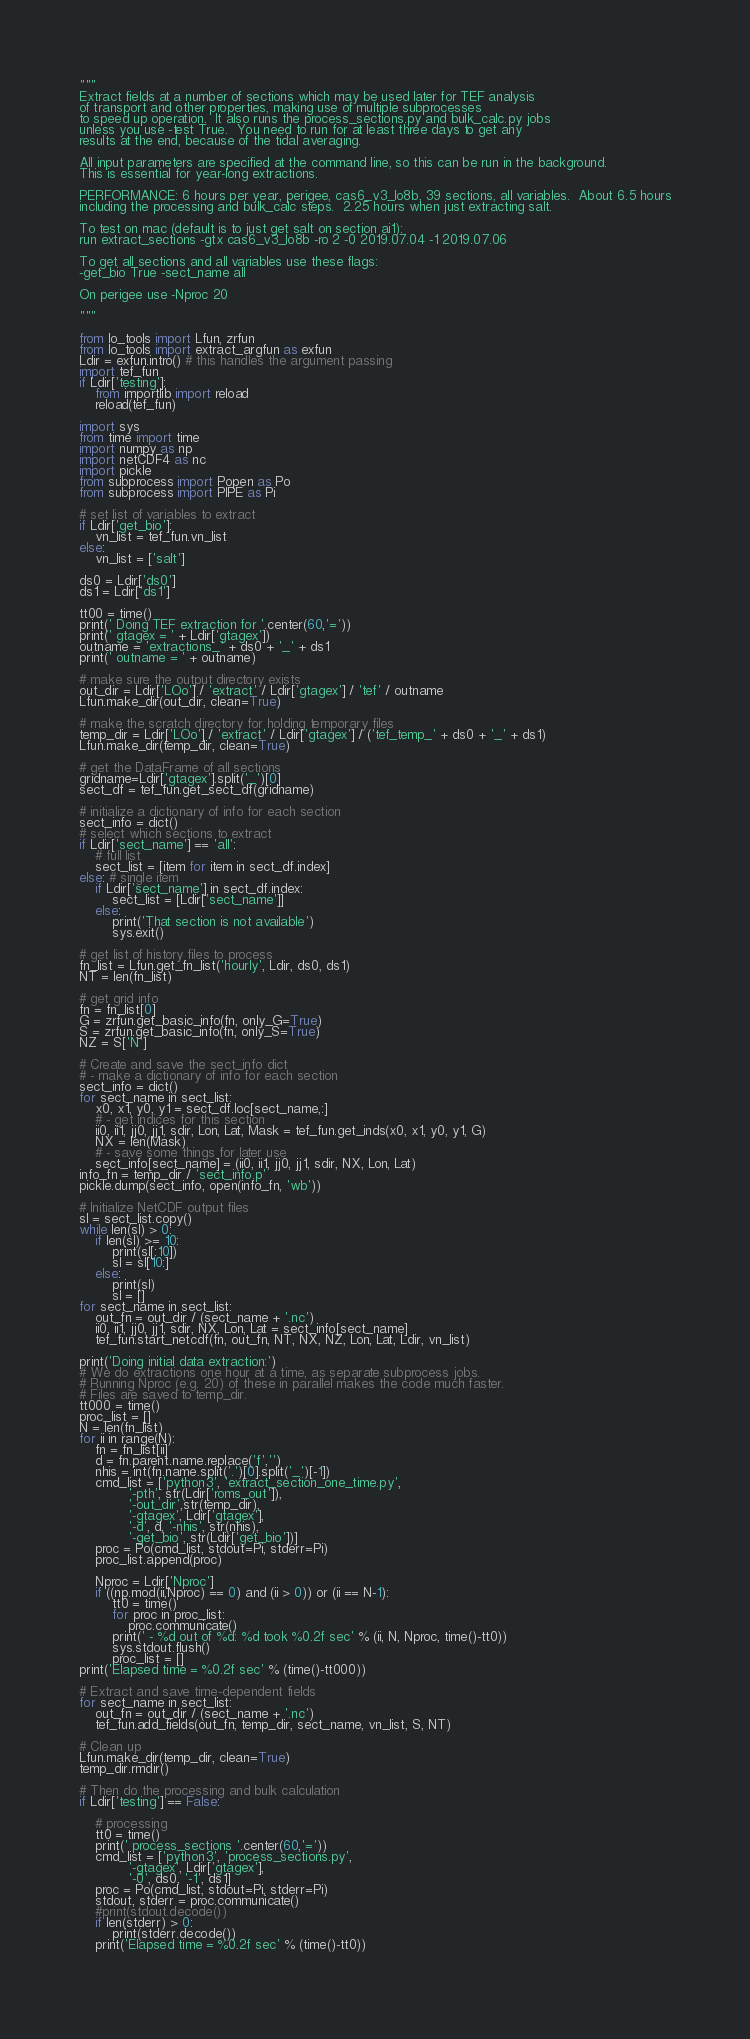<code> <loc_0><loc_0><loc_500><loc_500><_Python_>"""
Extract fields at a number of sections which may be used later for TEF analysis
of transport and other properties, making use of multiple subprocesses
to speed up operation.  It also runs the process_sections.py and bulk_calc.py jobs
unless you use -test True.  You need to run for at least three days to get any
results at the end, because of the tidal averaging.

All input parameters are specified at the command line, so this can be run in the background.
This is essential for year-long extractions.

PERFORMANCE: 6 hours per year, perigee, cas6_v3_lo8b, 39 sections, all variables.  About 6.5 hours
including the processing and bulk_calc steps.  2.25 hours when just extracting salt.

To test on mac (default is to just get salt on section ai1):
run extract_sections -gtx cas6_v3_lo8b -ro 2 -0 2019.07.04 -1 2019.07.06

To get all sections and all variables use these flags:
-get_bio True -sect_name all

On perigee use -Nproc 20

"""

from lo_tools import Lfun, zrfun
from lo_tools import extract_argfun as exfun
Ldir = exfun.intro() # this handles the argument passing
import tef_fun
if Ldir['testing']:
    from importlib import reload
    reload(tef_fun)

import sys
from time import time
import numpy as np
import netCDF4 as nc
import pickle
from subprocess import Popen as Po
from subprocess import PIPE as Pi
    
# set list of variables to extract
if Ldir['get_bio']:
    vn_list = tef_fun.vn_list
else:
    vn_list = ['salt']

ds0 = Ldir['ds0']
ds1 = Ldir['ds1']

tt00 = time()
print(' Doing TEF extraction for '.center(60,'='))
print(' gtagex = ' + Ldir['gtagex'])
outname = 'extractions_' + ds0 + '_' + ds1
print(' outname = ' + outname)

# make sure the output directory exists
out_dir = Ldir['LOo'] / 'extract' / Ldir['gtagex'] / 'tef' / outname
Lfun.make_dir(out_dir, clean=True)

# make the scratch directory for holding temporary files
temp_dir = Ldir['LOo'] / 'extract' / Ldir['gtagex'] / ('tef_temp_' + ds0 + '_' + ds1)
Lfun.make_dir(temp_dir, clean=True)

# get the DataFrame of all sections
gridname=Ldir['gtagex'].split('_')[0]
sect_df = tef_fun.get_sect_df(gridname)

# initialize a dictionary of info for each section
sect_info = dict()
# select which sections to extract
if Ldir['sect_name'] == 'all':
    # full list
    sect_list = [item for item in sect_df.index]
else: # single item
    if Ldir['sect_name'] in sect_df.index:
        sect_list = [Ldir['sect_name']]
    else:
        print('That section is not available')
        sys.exit()

# get list of history files to process
fn_list = Lfun.get_fn_list('hourly', Ldir, ds0, ds1)
NT = len(fn_list)

# get grid info
fn = fn_list[0]
G = zrfun.get_basic_info(fn, only_G=True)
S = zrfun.get_basic_info(fn, only_S=True)
NZ = S['N']

# Create and save the sect_info dict
# - make a dictionary of info for each section
sect_info = dict()
for sect_name in sect_list:
    x0, x1, y0, y1 = sect_df.loc[sect_name,:]
    # - get indices for this section
    ii0, ii1, jj0, jj1, sdir, Lon, Lat, Mask = tef_fun.get_inds(x0, x1, y0, y1, G)
    NX = len(Mask)
    # - save some things for later use
    sect_info[sect_name] = (ii0, ii1, jj0, jj1, sdir, NX, Lon, Lat)
info_fn = temp_dir / 'sect_info.p'
pickle.dump(sect_info, open(info_fn, 'wb'))

# Initialize NetCDF output files
sl = sect_list.copy()
while len(sl) > 0:
    if len(sl) >= 10:
        print(sl[:10])
        sl = sl[10:]
    else:
        print(sl)
        sl = []
for sect_name in sect_list:
    out_fn = out_dir / (sect_name + '.nc')
    ii0, ii1, jj0, jj1, sdir, NX, Lon, Lat = sect_info[sect_name]
    tef_fun.start_netcdf(fn, out_fn, NT, NX, NZ, Lon, Lat, Ldir, vn_list)

print('Doing initial data extraction:')
# We do extractions one hour at a time, as separate subprocess jobs.
# Running Nproc (e.g. 20) of these in parallel makes the code much faster.
# Files are saved to temp_dir.
tt000 = time()
proc_list = []
N = len(fn_list)
for ii in range(N):
    fn = fn_list[ii]
    d = fn.parent.name.replace('f','')
    nhis = int(fn.name.split('.')[0].split('_')[-1])
    cmd_list = ['python3', 'extract_section_one_time.py',
            '-pth', str(Ldir['roms_out']),
            '-out_dir',str(temp_dir),
            '-gtagex', Ldir['gtagex'],
            '-d', d, '-nhis', str(nhis),
            '-get_bio', str(Ldir['get_bio'])]
    proc = Po(cmd_list, stdout=Pi, stderr=Pi)
    proc_list.append(proc)
    
    Nproc = Ldir['Nproc']
    if ((np.mod(ii,Nproc) == 0) and (ii > 0)) or (ii == N-1):
        tt0 = time()
        for proc in proc_list:
            proc.communicate()
        print(' - %d out of %d: %d took %0.2f sec' % (ii, N, Nproc, time()-tt0))
        sys.stdout.flush()
        proc_list = []
print('Elapsed time = %0.2f sec' % (time()-tt000))

# Extract and save time-dependent fields
for sect_name in sect_list:
    out_fn = out_dir / (sect_name + '.nc')
    tef_fun.add_fields(out_fn, temp_dir, sect_name, vn_list, S, NT)
    
# Clean up
Lfun.make_dir(temp_dir, clean=True)
temp_dir.rmdir()

# Then do the processing and bulk calculation
if Ldir['testing'] == False:
    
    # processing
    tt0 = time()
    print(' process_sections '.center(60,'='))
    cmd_list = ['python3', 'process_sections.py',
            '-gtagex', Ldir['gtagex'],
            '-0', ds0, '-1', ds1]
    proc = Po(cmd_list, stdout=Pi, stderr=Pi)
    stdout, stderr = proc.communicate()
    #print(stdout.decode())
    if len(stderr) > 0:
        print(stderr.decode())
    print('Elapsed time = %0.2f sec' % (time()-tt0))
    </code> 